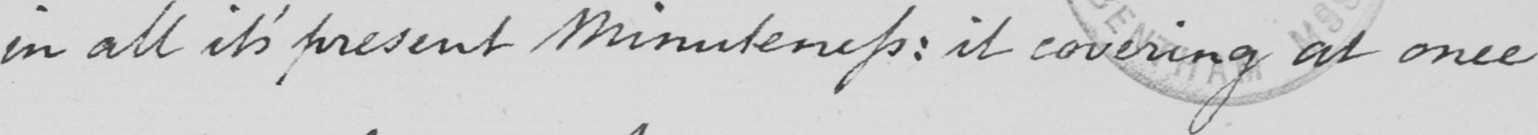What is written in this line of handwriting? in all its present Minuteness :  is covering at once 